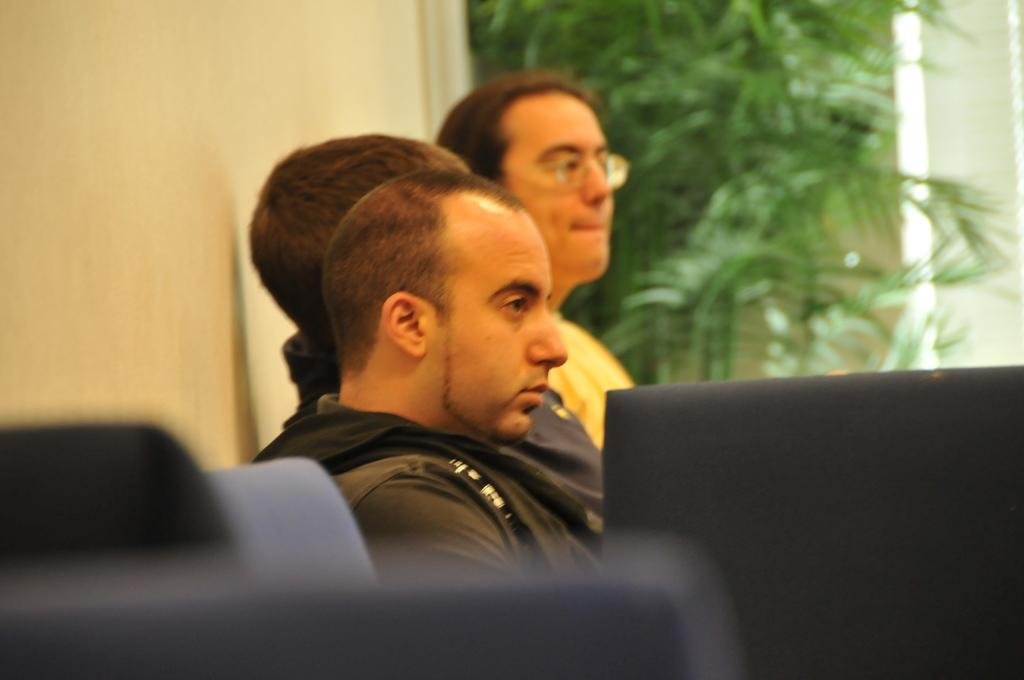How many people are in the image? There is a group of people in the image, but the exact number cannot be determined from the provided facts. What are the people in the image doing? The people are sitting in the image. What furniture is visible in the image? There are chairs in the image. What type of vegetation can be seen in the image? There are plants visible in the image. What type of test can be seen being conducted in the image? There is no test visible in the image; it features a group of people sitting with chairs and plants. Can you describe the frog sitting on the chair in the image? There is no frog present in the image. 